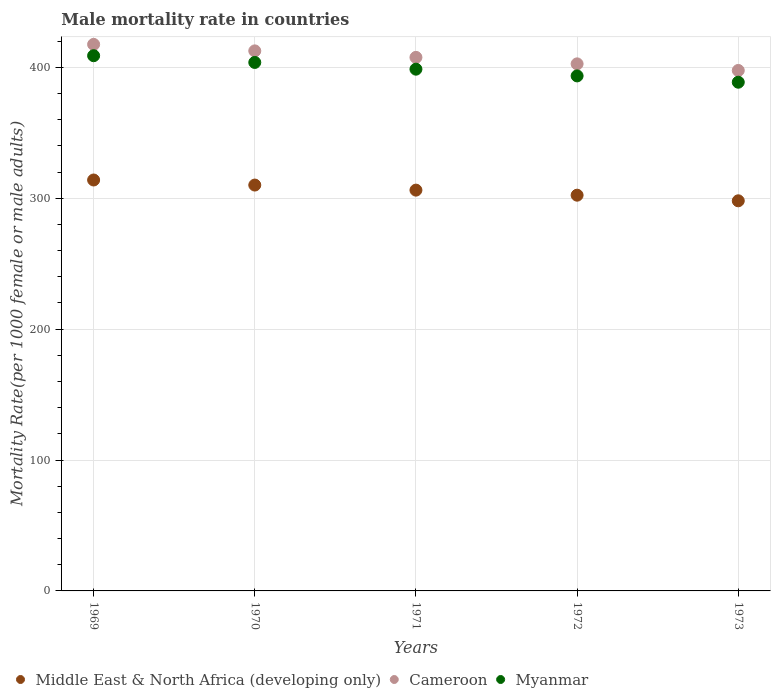What is the male mortality rate in Cameroon in 1969?
Offer a terse response. 417.58. Across all years, what is the maximum male mortality rate in Middle East & North Africa (developing only)?
Offer a terse response. 313.97. Across all years, what is the minimum male mortality rate in Cameroon?
Offer a terse response. 397.67. In which year was the male mortality rate in Middle East & North Africa (developing only) maximum?
Provide a short and direct response. 1969. What is the total male mortality rate in Middle East & North Africa (developing only) in the graph?
Offer a very short reply. 1530.75. What is the difference between the male mortality rate in Middle East & North Africa (developing only) in 1969 and that in 1972?
Give a very brief answer. 11.61. What is the difference between the male mortality rate in Middle East & North Africa (developing only) in 1973 and the male mortality rate in Cameroon in 1972?
Provide a short and direct response. -104.63. What is the average male mortality rate in Middle East & North Africa (developing only) per year?
Offer a very short reply. 306.15. In the year 1970, what is the difference between the male mortality rate in Middle East & North Africa (developing only) and male mortality rate in Myanmar?
Keep it short and to the point. -93.69. In how many years, is the male mortality rate in Cameroon greater than 200?
Your answer should be compact. 5. What is the ratio of the male mortality rate in Middle East & North Africa (developing only) in 1971 to that in 1973?
Offer a terse response. 1.03. Is the male mortality rate in Cameroon in 1970 less than that in 1973?
Make the answer very short. No. What is the difference between the highest and the second highest male mortality rate in Myanmar?
Ensure brevity in your answer.  5.14. What is the difference between the highest and the lowest male mortality rate in Middle East & North Africa (developing only)?
Keep it short and to the point. 15.89. In how many years, is the male mortality rate in Myanmar greater than the average male mortality rate in Myanmar taken over all years?
Your answer should be compact. 2. Is the male mortality rate in Cameroon strictly greater than the male mortality rate in Myanmar over the years?
Provide a succinct answer. Yes. How many dotlines are there?
Ensure brevity in your answer.  3. What is the difference between two consecutive major ticks on the Y-axis?
Give a very brief answer. 100. Does the graph contain grids?
Your response must be concise. Yes. Where does the legend appear in the graph?
Make the answer very short. Bottom left. How are the legend labels stacked?
Keep it short and to the point. Horizontal. What is the title of the graph?
Make the answer very short. Male mortality rate in countries. Does "Syrian Arab Republic" appear as one of the legend labels in the graph?
Your response must be concise. No. What is the label or title of the X-axis?
Keep it short and to the point. Years. What is the label or title of the Y-axis?
Offer a very short reply. Mortality Rate(per 1000 female or male adults). What is the Mortality Rate(per 1000 female or male adults) in Middle East & North Africa (developing only) in 1969?
Your response must be concise. 313.97. What is the Mortality Rate(per 1000 female or male adults) of Cameroon in 1969?
Keep it short and to the point. 417.58. What is the Mortality Rate(per 1000 female or male adults) of Myanmar in 1969?
Provide a short and direct response. 408.94. What is the Mortality Rate(per 1000 female or male adults) of Middle East & North Africa (developing only) in 1970?
Make the answer very short. 310.1. What is the Mortality Rate(per 1000 female or male adults) in Cameroon in 1970?
Your answer should be very brief. 412.62. What is the Mortality Rate(per 1000 female or male adults) in Myanmar in 1970?
Keep it short and to the point. 403.79. What is the Mortality Rate(per 1000 female or male adults) of Middle East & North Africa (developing only) in 1971?
Your response must be concise. 306.23. What is the Mortality Rate(per 1000 female or male adults) in Cameroon in 1971?
Provide a short and direct response. 407.66. What is the Mortality Rate(per 1000 female or male adults) of Myanmar in 1971?
Make the answer very short. 398.65. What is the Mortality Rate(per 1000 female or male adults) in Middle East & North Africa (developing only) in 1972?
Make the answer very short. 302.37. What is the Mortality Rate(per 1000 female or male adults) in Cameroon in 1972?
Keep it short and to the point. 402.7. What is the Mortality Rate(per 1000 female or male adults) of Myanmar in 1972?
Make the answer very short. 393.5. What is the Mortality Rate(per 1000 female or male adults) in Middle East & North Africa (developing only) in 1973?
Keep it short and to the point. 298.08. What is the Mortality Rate(per 1000 female or male adults) in Cameroon in 1973?
Provide a succinct answer. 397.67. What is the Mortality Rate(per 1000 female or male adults) in Myanmar in 1973?
Your response must be concise. 388.68. Across all years, what is the maximum Mortality Rate(per 1000 female or male adults) in Middle East & North Africa (developing only)?
Offer a very short reply. 313.97. Across all years, what is the maximum Mortality Rate(per 1000 female or male adults) of Cameroon?
Your answer should be very brief. 417.58. Across all years, what is the maximum Mortality Rate(per 1000 female or male adults) in Myanmar?
Keep it short and to the point. 408.94. Across all years, what is the minimum Mortality Rate(per 1000 female or male adults) in Middle East & North Africa (developing only)?
Offer a terse response. 298.08. Across all years, what is the minimum Mortality Rate(per 1000 female or male adults) of Cameroon?
Offer a very short reply. 397.67. Across all years, what is the minimum Mortality Rate(per 1000 female or male adults) in Myanmar?
Your answer should be compact. 388.68. What is the total Mortality Rate(per 1000 female or male adults) in Middle East & North Africa (developing only) in the graph?
Your answer should be very brief. 1530.75. What is the total Mortality Rate(per 1000 female or male adults) of Cameroon in the graph?
Your answer should be compact. 2038.23. What is the total Mortality Rate(per 1000 female or male adults) in Myanmar in the graph?
Make the answer very short. 1993.56. What is the difference between the Mortality Rate(per 1000 female or male adults) of Middle East & North Africa (developing only) in 1969 and that in 1970?
Make the answer very short. 3.87. What is the difference between the Mortality Rate(per 1000 female or male adults) of Cameroon in 1969 and that in 1970?
Your answer should be very brief. 4.96. What is the difference between the Mortality Rate(per 1000 female or male adults) in Myanmar in 1969 and that in 1970?
Your response must be concise. 5.14. What is the difference between the Mortality Rate(per 1000 female or male adults) in Middle East & North Africa (developing only) in 1969 and that in 1971?
Make the answer very short. 7.74. What is the difference between the Mortality Rate(per 1000 female or male adults) in Cameroon in 1969 and that in 1971?
Provide a short and direct response. 9.92. What is the difference between the Mortality Rate(per 1000 female or male adults) of Myanmar in 1969 and that in 1971?
Your answer should be very brief. 10.29. What is the difference between the Mortality Rate(per 1000 female or male adults) in Middle East & North Africa (developing only) in 1969 and that in 1972?
Provide a short and direct response. 11.61. What is the difference between the Mortality Rate(per 1000 female or male adults) in Cameroon in 1969 and that in 1972?
Ensure brevity in your answer.  14.88. What is the difference between the Mortality Rate(per 1000 female or male adults) in Myanmar in 1969 and that in 1972?
Offer a terse response. 15.43. What is the difference between the Mortality Rate(per 1000 female or male adults) in Middle East & North Africa (developing only) in 1969 and that in 1973?
Your response must be concise. 15.89. What is the difference between the Mortality Rate(per 1000 female or male adults) in Cameroon in 1969 and that in 1973?
Offer a terse response. 19.91. What is the difference between the Mortality Rate(per 1000 female or male adults) of Myanmar in 1969 and that in 1973?
Provide a succinct answer. 20.25. What is the difference between the Mortality Rate(per 1000 female or male adults) of Middle East & North Africa (developing only) in 1970 and that in 1971?
Your answer should be compact. 3.87. What is the difference between the Mortality Rate(per 1000 female or male adults) in Cameroon in 1970 and that in 1971?
Make the answer very short. 4.96. What is the difference between the Mortality Rate(per 1000 female or male adults) in Myanmar in 1970 and that in 1971?
Your answer should be compact. 5.14. What is the difference between the Mortality Rate(per 1000 female or male adults) of Middle East & North Africa (developing only) in 1970 and that in 1972?
Provide a short and direct response. 7.74. What is the difference between the Mortality Rate(per 1000 female or male adults) in Cameroon in 1970 and that in 1972?
Offer a very short reply. 9.92. What is the difference between the Mortality Rate(per 1000 female or male adults) in Myanmar in 1970 and that in 1972?
Your response must be concise. 10.29. What is the difference between the Mortality Rate(per 1000 female or male adults) in Middle East & North Africa (developing only) in 1970 and that in 1973?
Provide a succinct answer. 12.03. What is the difference between the Mortality Rate(per 1000 female or male adults) in Cameroon in 1970 and that in 1973?
Provide a short and direct response. 14.95. What is the difference between the Mortality Rate(per 1000 female or male adults) in Myanmar in 1970 and that in 1973?
Give a very brief answer. 15.11. What is the difference between the Mortality Rate(per 1000 female or male adults) of Middle East & North Africa (developing only) in 1971 and that in 1972?
Your answer should be compact. 3.87. What is the difference between the Mortality Rate(per 1000 female or male adults) of Cameroon in 1971 and that in 1972?
Ensure brevity in your answer.  4.96. What is the difference between the Mortality Rate(per 1000 female or male adults) in Myanmar in 1971 and that in 1972?
Your answer should be compact. 5.14. What is the difference between the Mortality Rate(per 1000 female or male adults) in Middle East & North Africa (developing only) in 1971 and that in 1973?
Offer a terse response. 8.16. What is the difference between the Mortality Rate(per 1000 female or male adults) in Cameroon in 1971 and that in 1973?
Your response must be concise. 9.99. What is the difference between the Mortality Rate(per 1000 female or male adults) in Myanmar in 1971 and that in 1973?
Offer a terse response. 9.96. What is the difference between the Mortality Rate(per 1000 female or male adults) of Middle East & North Africa (developing only) in 1972 and that in 1973?
Provide a short and direct response. 4.29. What is the difference between the Mortality Rate(per 1000 female or male adults) of Cameroon in 1972 and that in 1973?
Your answer should be compact. 5.03. What is the difference between the Mortality Rate(per 1000 female or male adults) of Myanmar in 1972 and that in 1973?
Give a very brief answer. 4.82. What is the difference between the Mortality Rate(per 1000 female or male adults) in Middle East & North Africa (developing only) in 1969 and the Mortality Rate(per 1000 female or male adults) in Cameroon in 1970?
Your answer should be compact. -98.65. What is the difference between the Mortality Rate(per 1000 female or male adults) in Middle East & North Africa (developing only) in 1969 and the Mortality Rate(per 1000 female or male adults) in Myanmar in 1970?
Give a very brief answer. -89.82. What is the difference between the Mortality Rate(per 1000 female or male adults) of Cameroon in 1969 and the Mortality Rate(per 1000 female or male adults) of Myanmar in 1970?
Give a very brief answer. 13.79. What is the difference between the Mortality Rate(per 1000 female or male adults) in Middle East & North Africa (developing only) in 1969 and the Mortality Rate(per 1000 female or male adults) in Cameroon in 1971?
Keep it short and to the point. -93.69. What is the difference between the Mortality Rate(per 1000 female or male adults) of Middle East & North Africa (developing only) in 1969 and the Mortality Rate(per 1000 female or male adults) of Myanmar in 1971?
Ensure brevity in your answer.  -84.68. What is the difference between the Mortality Rate(per 1000 female or male adults) in Cameroon in 1969 and the Mortality Rate(per 1000 female or male adults) in Myanmar in 1971?
Ensure brevity in your answer.  18.93. What is the difference between the Mortality Rate(per 1000 female or male adults) in Middle East & North Africa (developing only) in 1969 and the Mortality Rate(per 1000 female or male adults) in Cameroon in 1972?
Your response must be concise. -88.73. What is the difference between the Mortality Rate(per 1000 female or male adults) in Middle East & North Africa (developing only) in 1969 and the Mortality Rate(per 1000 female or male adults) in Myanmar in 1972?
Offer a very short reply. -79.53. What is the difference between the Mortality Rate(per 1000 female or male adults) in Cameroon in 1969 and the Mortality Rate(per 1000 female or male adults) in Myanmar in 1972?
Offer a very short reply. 24.08. What is the difference between the Mortality Rate(per 1000 female or male adults) in Middle East & North Africa (developing only) in 1969 and the Mortality Rate(per 1000 female or male adults) in Cameroon in 1973?
Make the answer very short. -83.7. What is the difference between the Mortality Rate(per 1000 female or male adults) of Middle East & North Africa (developing only) in 1969 and the Mortality Rate(per 1000 female or male adults) of Myanmar in 1973?
Offer a terse response. -74.71. What is the difference between the Mortality Rate(per 1000 female or male adults) in Cameroon in 1969 and the Mortality Rate(per 1000 female or male adults) in Myanmar in 1973?
Ensure brevity in your answer.  28.9. What is the difference between the Mortality Rate(per 1000 female or male adults) of Middle East & North Africa (developing only) in 1970 and the Mortality Rate(per 1000 female or male adults) of Cameroon in 1971?
Provide a succinct answer. -97.56. What is the difference between the Mortality Rate(per 1000 female or male adults) of Middle East & North Africa (developing only) in 1970 and the Mortality Rate(per 1000 female or male adults) of Myanmar in 1971?
Offer a very short reply. -88.54. What is the difference between the Mortality Rate(per 1000 female or male adults) of Cameroon in 1970 and the Mortality Rate(per 1000 female or male adults) of Myanmar in 1971?
Your response must be concise. 13.97. What is the difference between the Mortality Rate(per 1000 female or male adults) in Middle East & North Africa (developing only) in 1970 and the Mortality Rate(per 1000 female or male adults) in Cameroon in 1972?
Give a very brief answer. -92.6. What is the difference between the Mortality Rate(per 1000 female or male adults) in Middle East & North Africa (developing only) in 1970 and the Mortality Rate(per 1000 female or male adults) in Myanmar in 1972?
Ensure brevity in your answer.  -83.4. What is the difference between the Mortality Rate(per 1000 female or male adults) of Cameroon in 1970 and the Mortality Rate(per 1000 female or male adults) of Myanmar in 1972?
Offer a very short reply. 19.12. What is the difference between the Mortality Rate(per 1000 female or male adults) in Middle East & North Africa (developing only) in 1970 and the Mortality Rate(per 1000 female or male adults) in Cameroon in 1973?
Provide a succinct answer. -87.56. What is the difference between the Mortality Rate(per 1000 female or male adults) of Middle East & North Africa (developing only) in 1970 and the Mortality Rate(per 1000 female or male adults) of Myanmar in 1973?
Offer a very short reply. -78.58. What is the difference between the Mortality Rate(per 1000 female or male adults) in Cameroon in 1970 and the Mortality Rate(per 1000 female or male adults) in Myanmar in 1973?
Your response must be concise. 23.94. What is the difference between the Mortality Rate(per 1000 female or male adults) in Middle East & North Africa (developing only) in 1971 and the Mortality Rate(per 1000 female or male adults) in Cameroon in 1972?
Ensure brevity in your answer.  -96.47. What is the difference between the Mortality Rate(per 1000 female or male adults) in Middle East & North Africa (developing only) in 1971 and the Mortality Rate(per 1000 female or male adults) in Myanmar in 1972?
Offer a very short reply. -87.27. What is the difference between the Mortality Rate(per 1000 female or male adults) of Cameroon in 1971 and the Mortality Rate(per 1000 female or male adults) of Myanmar in 1972?
Ensure brevity in your answer.  14.16. What is the difference between the Mortality Rate(per 1000 female or male adults) of Middle East & North Africa (developing only) in 1971 and the Mortality Rate(per 1000 female or male adults) of Cameroon in 1973?
Ensure brevity in your answer.  -91.44. What is the difference between the Mortality Rate(per 1000 female or male adults) in Middle East & North Africa (developing only) in 1971 and the Mortality Rate(per 1000 female or male adults) in Myanmar in 1973?
Your answer should be very brief. -82.45. What is the difference between the Mortality Rate(per 1000 female or male adults) of Cameroon in 1971 and the Mortality Rate(per 1000 female or male adults) of Myanmar in 1973?
Your response must be concise. 18.98. What is the difference between the Mortality Rate(per 1000 female or male adults) of Middle East & North Africa (developing only) in 1972 and the Mortality Rate(per 1000 female or male adults) of Cameroon in 1973?
Provide a short and direct response. -95.3. What is the difference between the Mortality Rate(per 1000 female or male adults) in Middle East & North Africa (developing only) in 1972 and the Mortality Rate(per 1000 female or male adults) in Myanmar in 1973?
Offer a terse response. -86.32. What is the difference between the Mortality Rate(per 1000 female or male adults) in Cameroon in 1972 and the Mortality Rate(per 1000 female or male adults) in Myanmar in 1973?
Offer a terse response. 14.02. What is the average Mortality Rate(per 1000 female or male adults) of Middle East & North Africa (developing only) per year?
Keep it short and to the point. 306.15. What is the average Mortality Rate(per 1000 female or male adults) of Cameroon per year?
Give a very brief answer. 407.65. What is the average Mortality Rate(per 1000 female or male adults) in Myanmar per year?
Offer a very short reply. 398.71. In the year 1969, what is the difference between the Mortality Rate(per 1000 female or male adults) of Middle East & North Africa (developing only) and Mortality Rate(per 1000 female or male adults) of Cameroon?
Make the answer very short. -103.61. In the year 1969, what is the difference between the Mortality Rate(per 1000 female or male adults) of Middle East & North Africa (developing only) and Mortality Rate(per 1000 female or male adults) of Myanmar?
Keep it short and to the point. -94.96. In the year 1969, what is the difference between the Mortality Rate(per 1000 female or male adults) in Cameroon and Mortality Rate(per 1000 female or male adults) in Myanmar?
Give a very brief answer. 8.64. In the year 1970, what is the difference between the Mortality Rate(per 1000 female or male adults) in Middle East & North Africa (developing only) and Mortality Rate(per 1000 female or male adults) in Cameroon?
Offer a terse response. -102.52. In the year 1970, what is the difference between the Mortality Rate(per 1000 female or male adults) of Middle East & North Africa (developing only) and Mortality Rate(per 1000 female or male adults) of Myanmar?
Offer a terse response. -93.69. In the year 1970, what is the difference between the Mortality Rate(per 1000 female or male adults) in Cameroon and Mortality Rate(per 1000 female or male adults) in Myanmar?
Keep it short and to the point. 8.83. In the year 1971, what is the difference between the Mortality Rate(per 1000 female or male adults) of Middle East & North Africa (developing only) and Mortality Rate(per 1000 female or male adults) of Cameroon?
Keep it short and to the point. -101.43. In the year 1971, what is the difference between the Mortality Rate(per 1000 female or male adults) of Middle East & North Africa (developing only) and Mortality Rate(per 1000 female or male adults) of Myanmar?
Provide a succinct answer. -92.42. In the year 1971, what is the difference between the Mortality Rate(per 1000 female or male adults) of Cameroon and Mortality Rate(per 1000 female or male adults) of Myanmar?
Give a very brief answer. 9.01. In the year 1972, what is the difference between the Mortality Rate(per 1000 female or male adults) of Middle East & North Africa (developing only) and Mortality Rate(per 1000 female or male adults) of Cameroon?
Ensure brevity in your answer.  -100.34. In the year 1972, what is the difference between the Mortality Rate(per 1000 female or male adults) of Middle East & North Africa (developing only) and Mortality Rate(per 1000 female or male adults) of Myanmar?
Your response must be concise. -91.14. In the year 1972, what is the difference between the Mortality Rate(per 1000 female or male adults) of Cameroon and Mortality Rate(per 1000 female or male adults) of Myanmar?
Offer a very short reply. 9.2. In the year 1973, what is the difference between the Mortality Rate(per 1000 female or male adults) in Middle East & North Africa (developing only) and Mortality Rate(per 1000 female or male adults) in Cameroon?
Offer a very short reply. -99.59. In the year 1973, what is the difference between the Mortality Rate(per 1000 female or male adults) of Middle East & North Africa (developing only) and Mortality Rate(per 1000 female or male adults) of Myanmar?
Ensure brevity in your answer.  -90.61. In the year 1973, what is the difference between the Mortality Rate(per 1000 female or male adults) in Cameroon and Mortality Rate(per 1000 female or male adults) in Myanmar?
Offer a very short reply. 8.99. What is the ratio of the Mortality Rate(per 1000 female or male adults) in Middle East & North Africa (developing only) in 1969 to that in 1970?
Give a very brief answer. 1.01. What is the ratio of the Mortality Rate(per 1000 female or male adults) in Cameroon in 1969 to that in 1970?
Your response must be concise. 1.01. What is the ratio of the Mortality Rate(per 1000 female or male adults) of Myanmar in 1969 to that in 1970?
Offer a terse response. 1.01. What is the ratio of the Mortality Rate(per 1000 female or male adults) of Middle East & North Africa (developing only) in 1969 to that in 1971?
Keep it short and to the point. 1.03. What is the ratio of the Mortality Rate(per 1000 female or male adults) in Cameroon in 1969 to that in 1971?
Give a very brief answer. 1.02. What is the ratio of the Mortality Rate(per 1000 female or male adults) in Myanmar in 1969 to that in 1971?
Provide a succinct answer. 1.03. What is the ratio of the Mortality Rate(per 1000 female or male adults) of Middle East & North Africa (developing only) in 1969 to that in 1972?
Your response must be concise. 1.04. What is the ratio of the Mortality Rate(per 1000 female or male adults) in Cameroon in 1969 to that in 1972?
Offer a terse response. 1.04. What is the ratio of the Mortality Rate(per 1000 female or male adults) in Myanmar in 1969 to that in 1972?
Offer a very short reply. 1.04. What is the ratio of the Mortality Rate(per 1000 female or male adults) in Middle East & North Africa (developing only) in 1969 to that in 1973?
Your answer should be compact. 1.05. What is the ratio of the Mortality Rate(per 1000 female or male adults) of Cameroon in 1969 to that in 1973?
Provide a succinct answer. 1.05. What is the ratio of the Mortality Rate(per 1000 female or male adults) in Myanmar in 1969 to that in 1973?
Give a very brief answer. 1.05. What is the ratio of the Mortality Rate(per 1000 female or male adults) of Middle East & North Africa (developing only) in 1970 to that in 1971?
Offer a very short reply. 1.01. What is the ratio of the Mortality Rate(per 1000 female or male adults) in Cameroon in 1970 to that in 1971?
Provide a succinct answer. 1.01. What is the ratio of the Mortality Rate(per 1000 female or male adults) in Myanmar in 1970 to that in 1971?
Offer a very short reply. 1.01. What is the ratio of the Mortality Rate(per 1000 female or male adults) of Middle East & North Africa (developing only) in 1970 to that in 1972?
Provide a succinct answer. 1.03. What is the ratio of the Mortality Rate(per 1000 female or male adults) in Cameroon in 1970 to that in 1972?
Ensure brevity in your answer.  1.02. What is the ratio of the Mortality Rate(per 1000 female or male adults) in Myanmar in 1970 to that in 1972?
Provide a short and direct response. 1.03. What is the ratio of the Mortality Rate(per 1000 female or male adults) of Middle East & North Africa (developing only) in 1970 to that in 1973?
Provide a short and direct response. 1.04. What is the ratio of the Mortality Rate(per 1000 female or male adults) of Cameroon in 1970 to that in 1973?
Your answer should be compact. 1.04. What is the ratio of the Mortality Rate(per 1000 female or male adults) in Myanmar in 1970 to that in 1973?
Offer a very short reply. 1.04. What is the ratio of the Mortality Rate(per 1000 female or male adults) of Middle East & North Africa (developing only) in 1971 to that in 1972?
Offer a very short reply. 1.01. What is the ratio of the Mortality Rate(per 1000 female or male adults) of Cameroon in 1971 to that in 1972?
Your answer should be compact. 1.01. What is the ratio of the Mortality Rate(per 1000 female or male adults) in Myanmar in 1971 to that in 1972?
Keep it short and to the point. 1.01. What is the ratio of the Mortality Rate(per 1000 female or male adults) in Middle East & North Africa (developing only) in 1971 to that in 1973?
Provide a short and direct response. 1.03. What is the ratio of the Mortality Rate(per 1000 female or male adults) of Cameroon in 1971 to that in 1973?
Offer a terse response. 1.03. What is the ratio of the Mortality Rate(per 1000 female or male adults) of Myanmar in 1971 to that in 1973?
Offer a very short reply. 1.03. What is the ratio of the Mortality Rate(per 1000 female or male adults) in Middle East & North Africa (developing only) in 1972 to that in 1973?
Ensure brevity in your answer.  1.01. What is the ratio of the Mortality Rate(per 1000 female or male adults) in Cameroon in 1972 to that in 1973?
Keep it short and to the point. 1.01. What is the ratio of the Mortality Rate(per 1000 female or male adults) in Myanmar in 1972 to that in 1973?
Ensure brevity in your answer.  1.01. What is the difference between the highest and the second highest Mortality Rate(per 1000 female or male adults) of Middle East & North Africa (developing only)?
Offer a very short reply. 3.87. What is the difference between the highest and the second highest Mortality Rate(per 1000 female or male adults) of Cameroon?
Give a very brief answer. 4.96. What is the difference between the highest and the second highest Mortality Rate(per 1000 female or male adults) in Myanmar?
Make the answer very short. 5.14. What is the difference between the highest and the lowest Mortality Rate(per 1000 female or male adults) of Middle East & North Africa (developing only)?
Keep it short and to the point. 15.89. What is the difference between the highest and the lowest Mortality Rate(per 1000 female or male adults) of Cameroon?
Offer a very short reply. 19.91. What is the difference between the highest and the lowest Mortality Rate(per 1000 female or male adults) in Myanmar?
Your answer should be very brief. 20.25. 